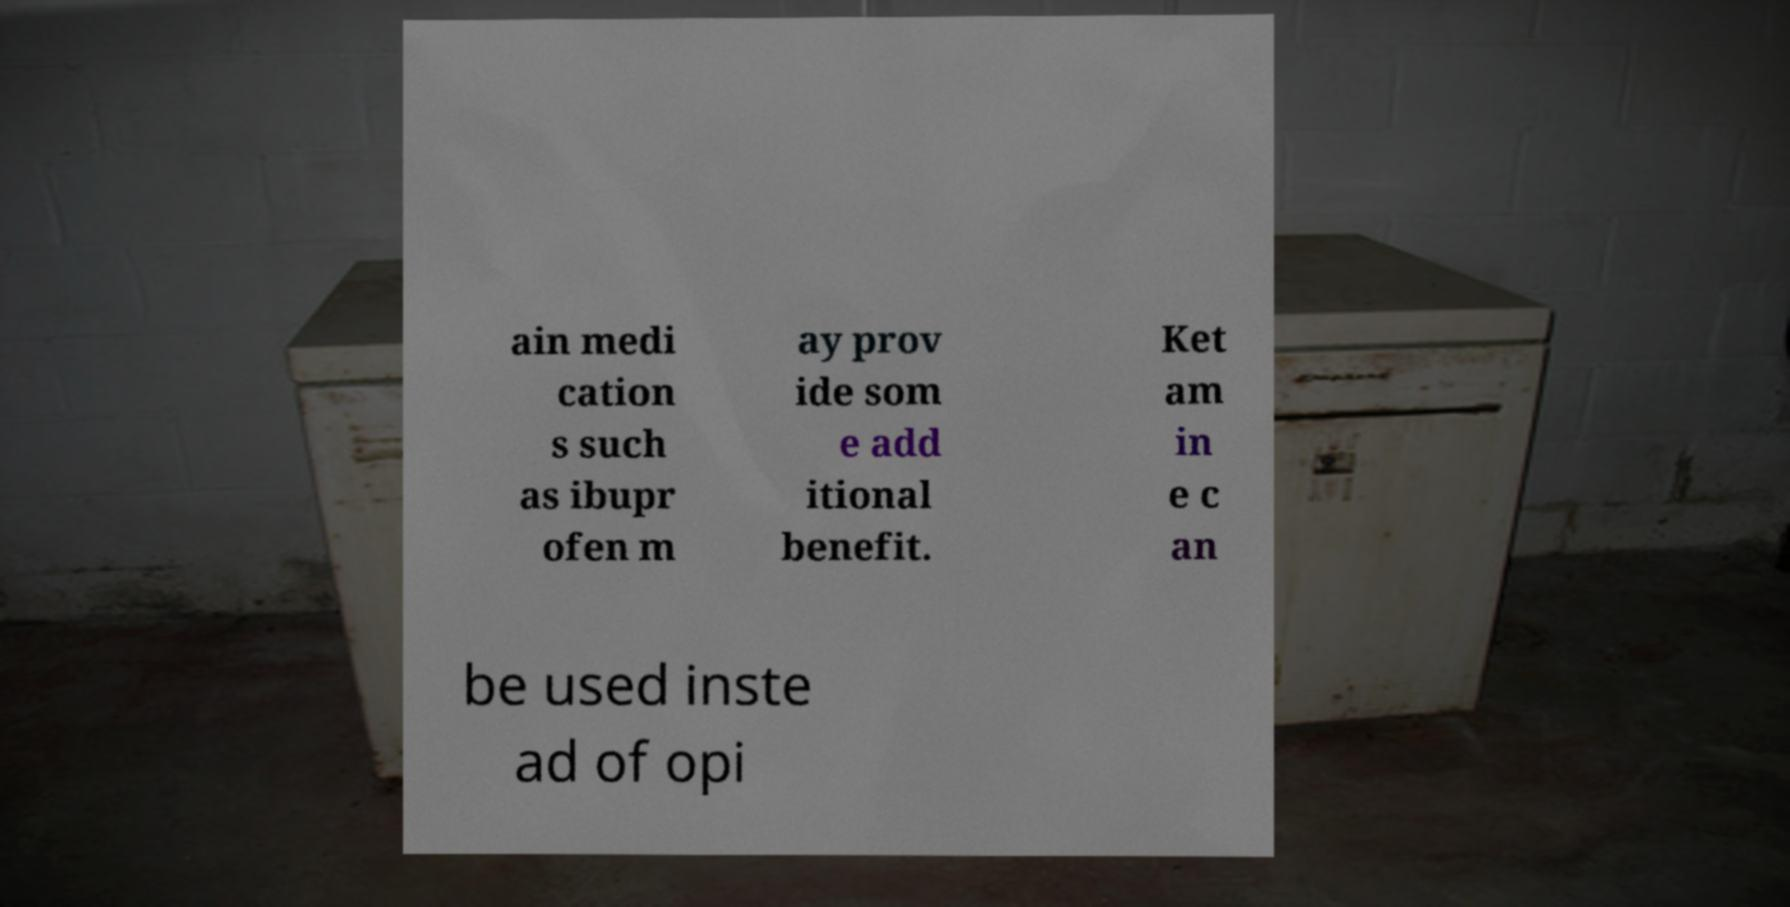For documentation purposes, I need the text within this image transcribed. Could you provide that? ain medi cation s such as ibupr ofen m ay prov ide som e add itional benefit. Ket am in e c an be used inste ad of opi 